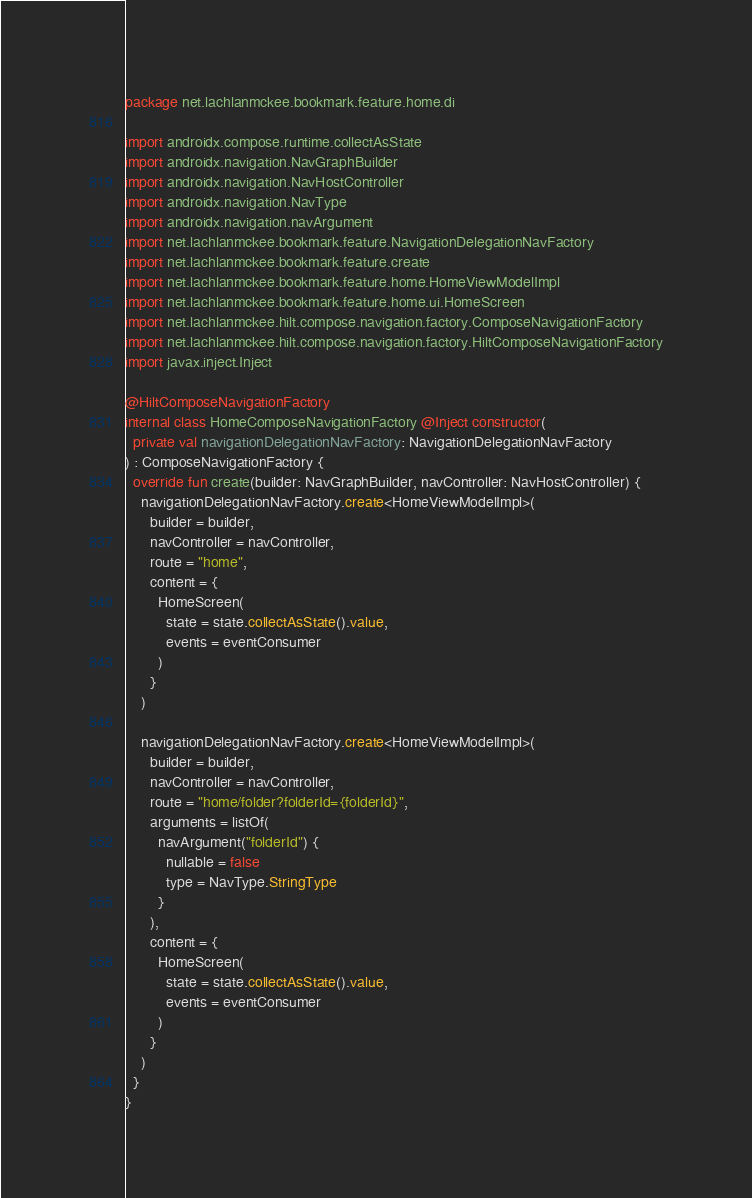<code> <loc_0><loc_0><loc_500><loc_500><_Kotlin_>package net.lachlanmckee.bookmark.feature.home.di

import androidx.compose.runtime.collectAsState
import androidx.navigation.NavGraphBuilder
import androidx.navigation.NavHostController
import androidx.navigation.NavType
import androidx.navigation.navArgument
import net.lachlanmckee.bookmark.feature.NavigationDelegationNavFactory
import net.lachlanmckee.bookmark.feature.create
import net.lachlanmckee.bookmark.feature.home.HomeViewModelImpl
import net.lachlanmckee.bookmark.feature.home.ui.HomeScreen
import net.lachlanmckee.hilt.compose.navigation.factory.ComposeNavigationFactory
import net.lachlanmckee.hilt.compose.navigation.factory.HiltComposeNavigationFactory
import javax.inject.Inject

@HiltComposeNavigationFactory
internal class HomeComposeNavigationFactory @Inject constructor(
  private val navigationDelegationNavFactory: NavigationDelegationNavFactory
) : ComposeNavigationFactory {
  override fun create(builder: NavGraphBuilder, navController: NavHostController) {
    navigationDelegationNavFactory.create<HomeViewModelImpl>(
      builder = builder,
      navController = navController,
      route = "home",
      content = {
        HomeScreen(
          state = state.collectAsState().value,
          events = eventConsumer
        )
      }
    )

    navigationDelegationNavFactory.create<HomeViewModelImpl>(
      builder = builder,
      navController = navController,
      route = "home/folder?folderId={folderId}",
      arguments = listOf(
        navArgument("folderId") {
          nullable = false
          type = NavType.StringType
        }
      ),
      content = {
        HomeScreen(
          state = state.collectAsState().value,
          events = eventConsumer
        )
      }
    )
  }
}
</code> 